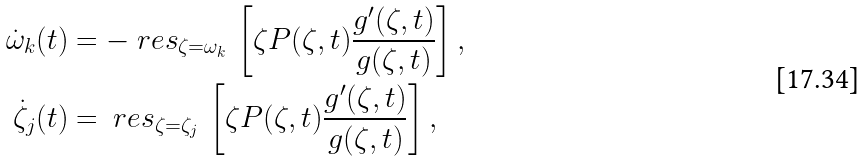<formula> <loc_0><loc_0><loc_500><loc_500>\dot { \omega } _ { k } ( t ) & = - { \ r e s } _ { \zeta = \omega _ { k } } \, \left [ \zeta P ( \zeta , t ) \frac { g ^ { \prime } ( \zeta , t ) } { g ( \zeta , t ) } \right ] , \\ \dot { \zeta } _ { j } ( t ) & = { \ r e s } _ { \zeta = \zeta _ { j } } \, \left [ \zeta P ( \zeta , t ) \frac { g ^ { \prime } ( \zeta , t ) } { g ( \zeta , t ) } \right ] ,</formula> 